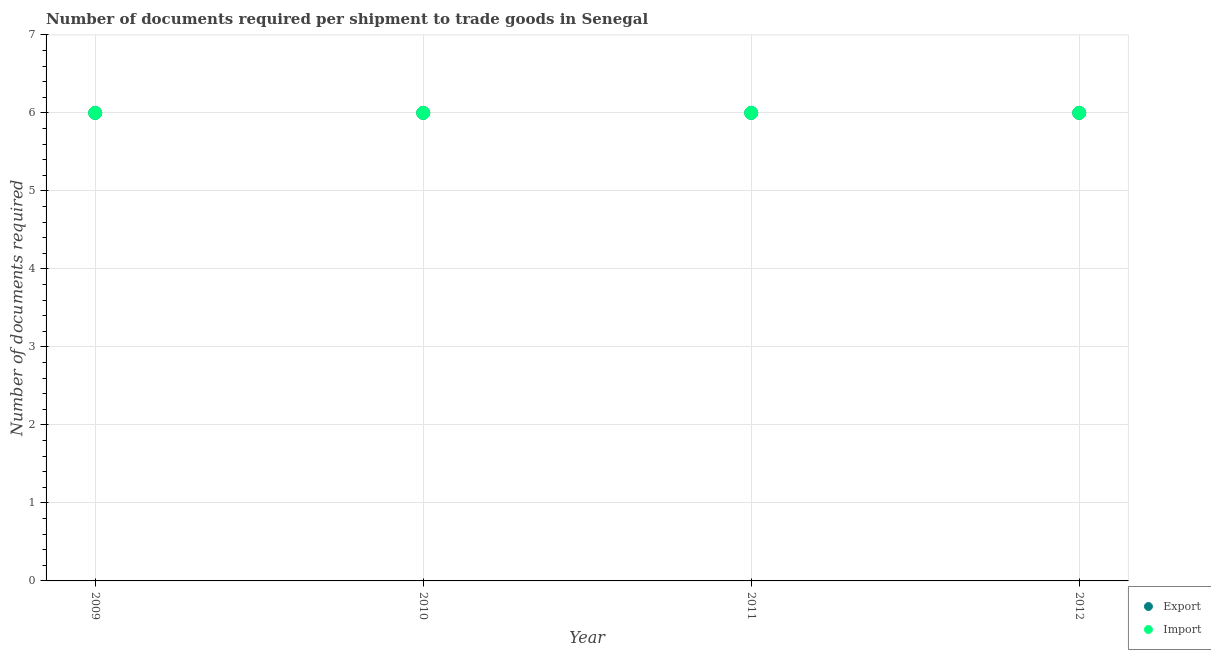How many different coloured dotlines are there?
Make the answer very short. 2. Across all years, what is the maximum number of documents required to export goods?
Make the answer very short. 6. Across all years, what is the minimum number of documents required to export goods?
Offer a very short reply. 6. In which year was the number of documents required to import goods maximum?
Ensure brevity in your answer.  2009. In which year was the number of documents required to export goods minimum?
Provide a short and direct response. 2009. What is the total number of documents required to import goods in the graph?
Provide a short and direct response. 24. What is the difference between the number of documents required to export goods in 2009 and that in 2011?
Provide a succinct answer. 0. In the year 2010, what is the difference between the number of documents required to export goods and number of documents required to import goods?
Provide a succinct answer. 0. In how many years, is the number of documents required to import goods greater than 2.6?
Your answer should be very brief. 4. What is the ratio of the number of documents required to export goods in 2009 to that in 2012?
Your answer should be compact. 1. Is the number of documents required to export goods in 2009 less than that in 2012?
Provide a succinct answer. No. What is the difference between the highest and the lowest number of documents required to import goods?
Your answer should be very brief. 0. In how many years, is the number of documents required to export goods greater than the average number of documents required to export goods taken over all years?
Give a very brief answer. 0. Is the number of documents required to import goods strictly greater than the number of documents required to export goods over the years?
Your answer should be compact. No. Is the number of documents required to export goods strictly less than the number of documents required to import goods over the years?
Your response must be concise. No. How many dotlines are there?
Provide a short and direct response. 2. What is the difference between two consecutive major ticks on the Y-axis?
Make the answer very short. 1. Does the graph contain any zero values?
Keep it short and to the point. No. Does the graph contain grids?
Make the answer very short. Yes. Where does the legend appear in the graph?
Your answer should be compact. Bottom right. How are the legend labels stacked?
Offer a very short reply. Vertical. What is the title of the graph?
Provide a short and direct response. Number of documents required per shipment to trade goods in Senegal. Does "Merchandise exports" appear as one of the legend labels in the graph?
Provide a short and direct response. No. What is the label or title of the X-axis?
Your answer should be very brief. Year. What is the label or title of the Y-axis?
Your response must be concise. Number of documents required. What is the Number of documents required in Export in 2009?
Keep it short and to the point. 6. What is the Number of documents required of Import in 2009?
Provide a short and direct response. 6. What is the Number of documents required of Export in 2010?
Keep it short and to the point. 6. What is the Number of documents required of Import in 2010?
Provide a short and direct response. 6. What is the Number of documents required in Export in 2012?
Your answer should be very brief. 6. Across all years, what is the maximum Number of documents required of Export?
Ensure brevity in your answer.  6. Across all years, what is the maximum Number of documents required in Import?
Provide a short and direct response. 6. Across all years, what is the minimum Number of documents required of Import?
Your response must be concise. 6. What is the total Number of documents required of Import in the graph?
Your response must be concise. 24. What is the difference between the Number of documents required in Import in 2009 and that in 2010?
Your response must be concise. 0. What is the difference between the Number of documents required in Export in 2009 and that in 2011?
Your answer should be compact. 0. What is the difference between the Number of documents required in Export in 2009 and that in 2012?
Offer a terse response. 0. What is the difference between the Number of documents required of Import in 2009 and that in 2012?
Provide a succinct answer. 0. What is the difference between the Number of documents required in Export in 2010 and that in 2011?
Your response must be concise. 0. What is the difference between the Number of documents required of Import in 2010 and that in 2012?
Your answer should be very brief. 0. What is the difference between the Number of documents required in Import in 2011 and that in 2012?
Keep it short and to the point. 0. What is the difference between the Number of documents required of Export in 2009 and the Number of documents required of Import in 2011?
Your response must be concise. 0. What is the difference between the Number of documents required of Export in 2009 and the Number of documents required of Import in 2012?
Provide a short and direct response. 0. What is the difference between the Number of documents required of Export in 2010 and the Number of documents required of Import in 2011?
Your answer should be compact. 0. What is the difference between the Number of documents required of Export in 2011 and the Number of documents required of Import in 2012?
Provide a succinct answer. 0. What is the average Number of documents required in Import per year?
Keep it short and to the point. 6. In the year 2010, what is the difference between the Number of documents required in Export and Number of documents required in Import?
Your response must be concise. 0. What is the ratio of the Number of documents required of Export in 2009 to that in 2010?
Offer a very short reply. 1. What is the ratio of the Number of documents required in Import in 2009 to that in 2010?
Keep it short and to the point. 1. What is the ratio of the Number of documents required in Import in 2009 to that in 2011?
Make the answer very short. 1. What is the ratio of the Number of documents required in Export in 2009 to that in 2012?
Provide a succinct answer. 1. What is the ratio of the Number of documents required in Import in 2009 to that in 2012?
Provide a succinct answer. 1. What is the ratio of the Number of documents required of Export in 2010 to that in 2011?
Give a very brief answer. 1. What is the ratio of the Number of documents required of Import in 2010 to that in 2011?
Your answer should be very brief. 1. What is the ratio of the Number of documents required in Export in 2010 to that in 2012?
Offer a very short reply. 1. What is the ratio of the Number of documents required in Import in 2010 to that in 2012?
Make the answer very short. 1. What is the difference between the highest and the second highest Number of documents required in Import?
Your answer should be compact. 0. What is the difference between the highest and the lowest Number of documents required in Import?
Make the answer very short. 0. 